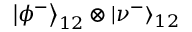<formula> <loc_0><loc_0><loc_500><loc_500>\left | \phi ^ { - } \right \rangle _ { 1 2 } \otimes \left | \nu ^ { - } \right \rangle _ { 1 2 }</formula> 